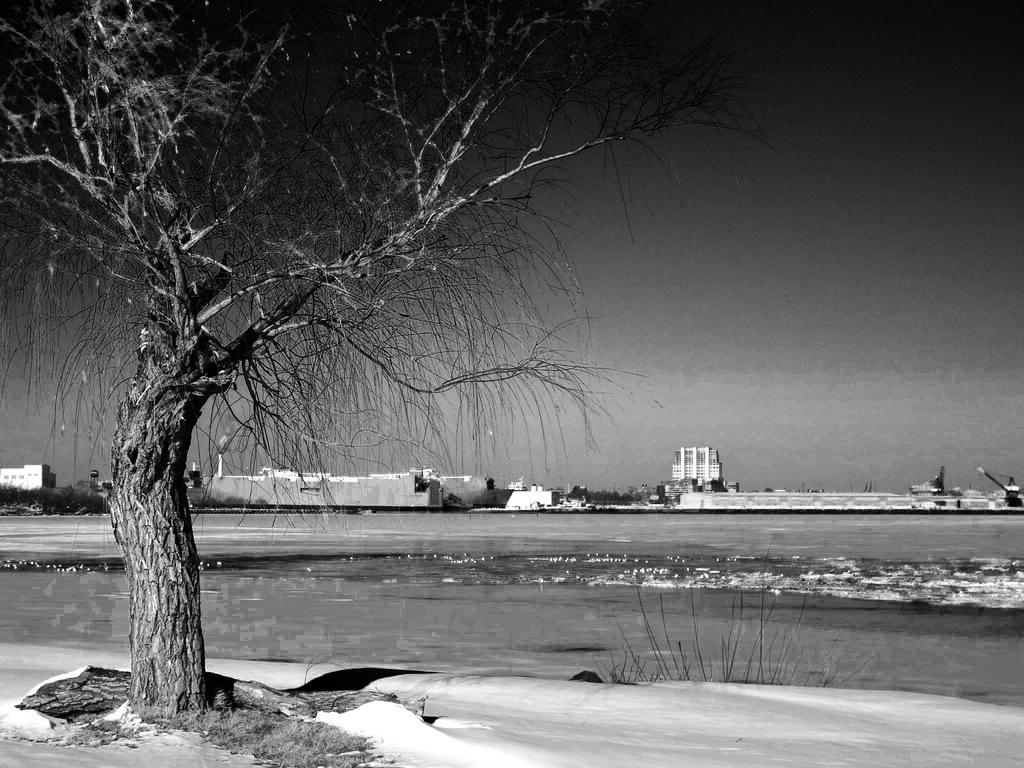What is the color scheme of the image? The image is black and white. What type of vegetation can be seen in the image? There is a tree and plants visible in the image. What is located in the water body in the image? There is a ship in the water body in the image. What type of structures are present in the image? There is a group of buildings in the image. What is the condition of the sky in the image? The sky is visible in the image and appears cloudy. What type of dress is the dad wearing in the image? There is no dad or dress present in the image. How many waves can be seen crashing against the ship in the image? There are no waves visible in the image; it only shows a ship in a water body. 